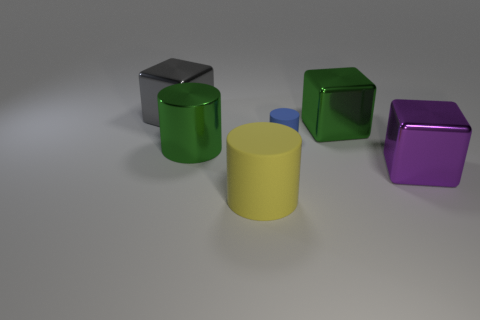Add 4 big yellow rubber cylinders. How many objects exist? 10 Add 2 metallic objects. How many metallic objects are left? 6 Add 2 blue things. How many blue things exist? 3 Subtract 0 cyan cylinders. How many objects are left? 6 Subtract all tiny things. Subtract all large yellow matte spheres. How many objects are left? 5 